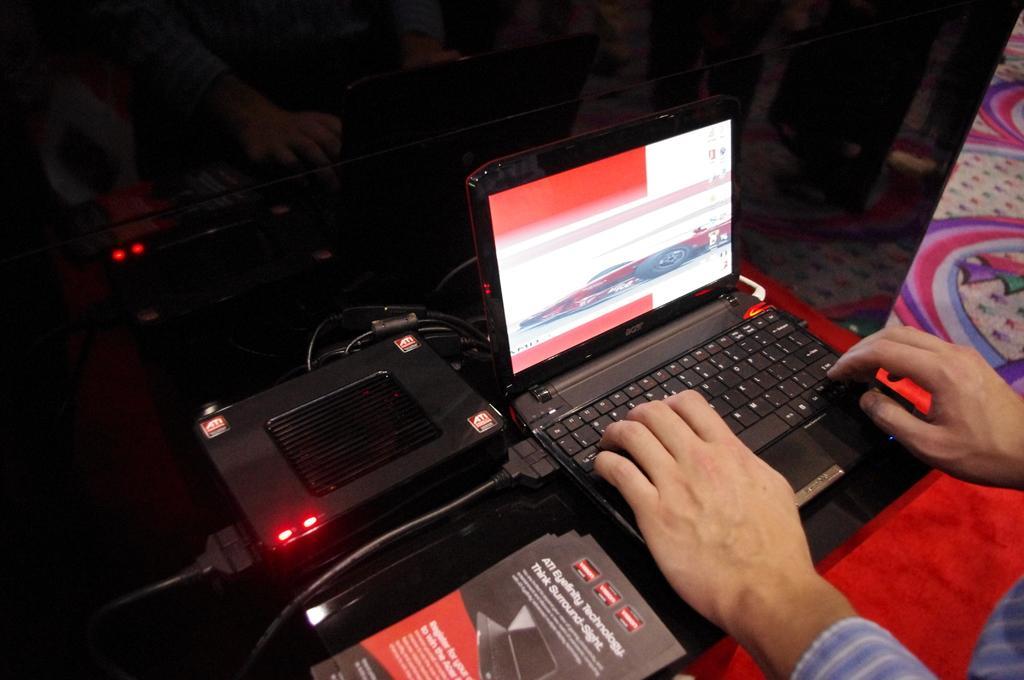Could you give a brief overview of what you see in this image? In this picture we can see laptop, router and other objects on the table. On the bottom right there is a person's hand who is working on the laptop. On the right we can see a carpet. 